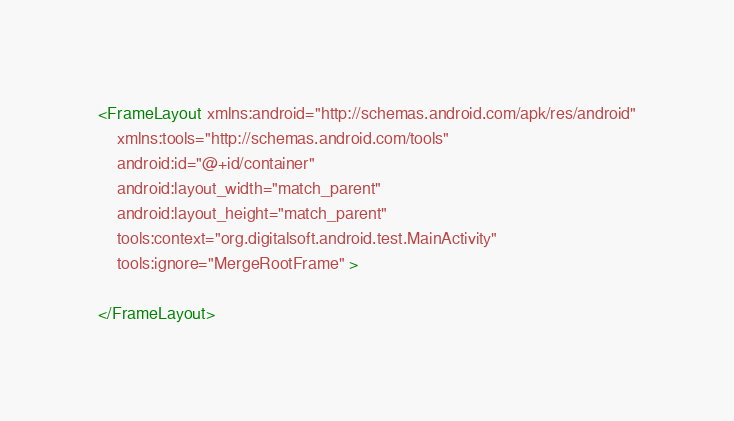Convert code to text. <code><loc_0><loc_0><loc_500><loc_500><_XML_><FrameLayout xmlns:android="http://schemas.android.com/apk/res/android"
    xmlns:tools="http://schemas.android.com/tools"
    android:id="@+id/container"
    android:layout_width="match_parent"
    android:layout_height="match_parent"
    tools:context="org.digitalsoft.android.test.MainActivity"
    tools:ignore="MergeRootFrame" >

</FrameLayout>
</code> 